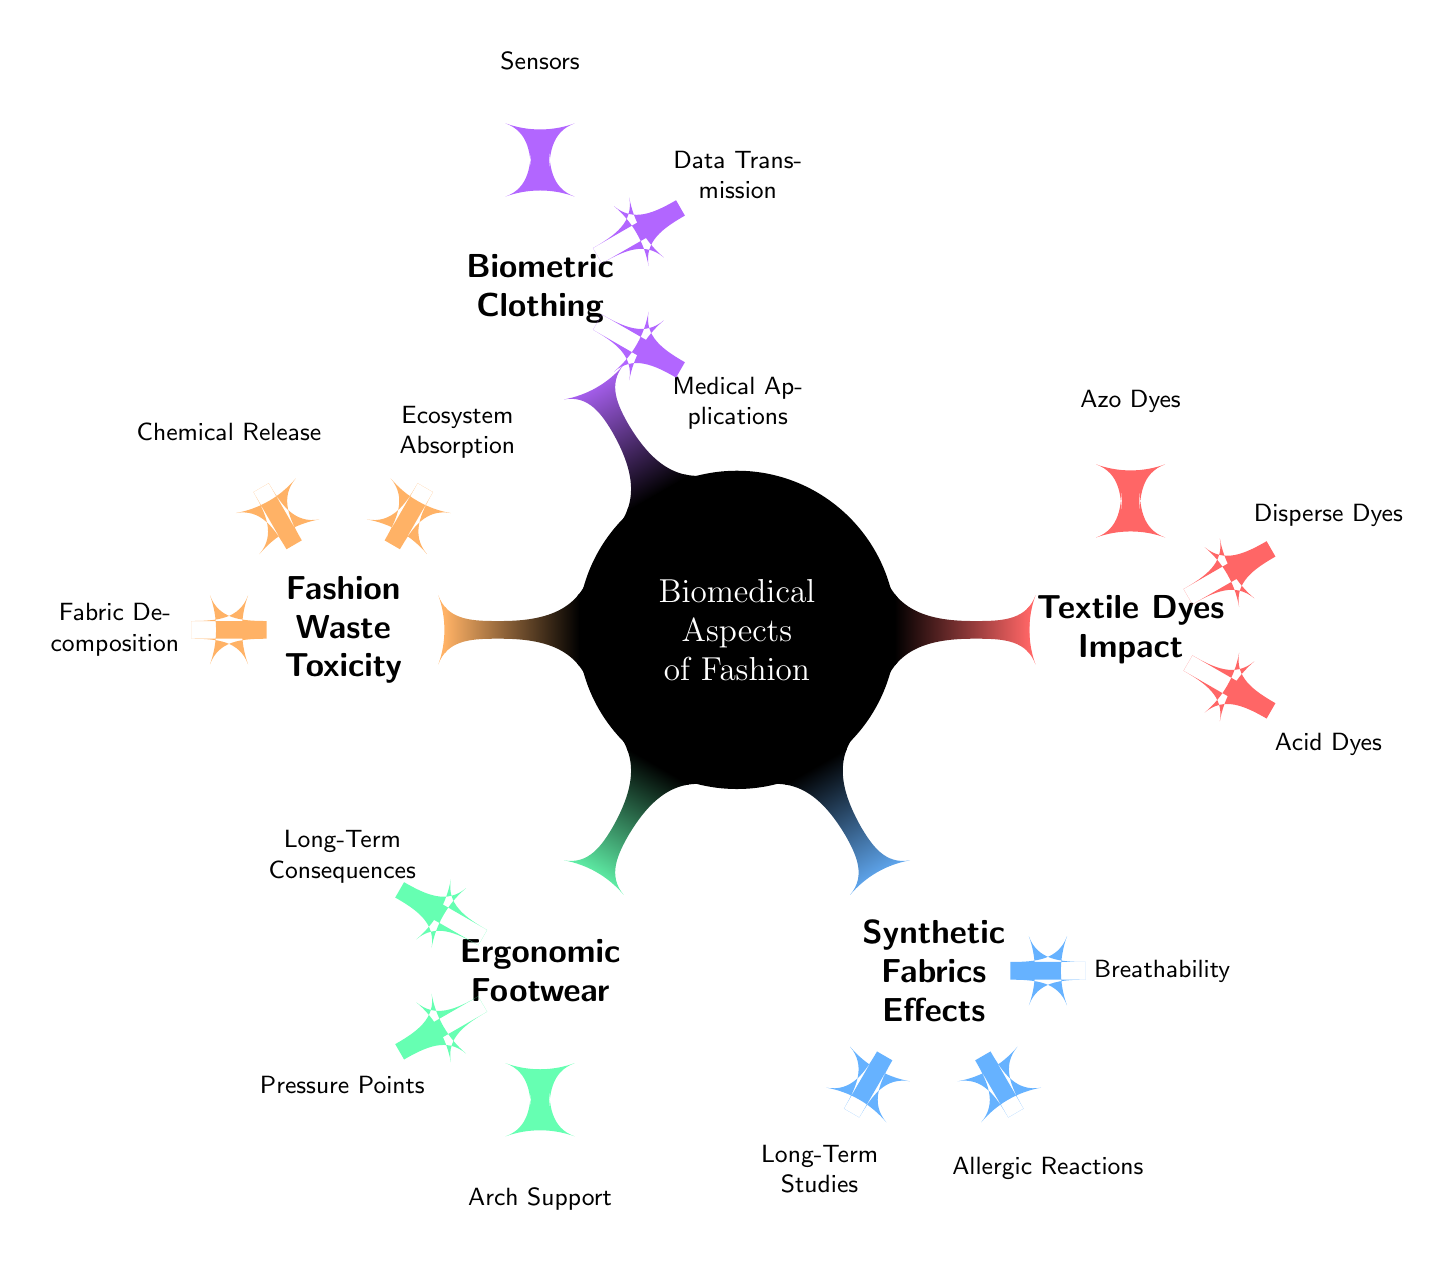What are the four main sections in the diagram? The diagram consists of five main sections: Textile Dyes Impact, Synthetic Fabrics Effects, Ergonomic Footwear, Fashion Waste Toxicity, and Biometric Clothing.
Answer: Textile Dyes Impact, Synthetic Fabrics Effects, Ergonomic Footwear, Fashion Waste Toxicity, Biometric Clothing How many types of textile dyes are identified in the diagram? There are three types of textile dyes identified in the diagram: Azo Dyes, Disperse Dyes, and Acid Dyes.
Answer: Three What is one health risk associated with synthetic fabrics? The diagram highlights Allergic Reactions as a potential health risk associated with synthetic fabrics.
Answer: Allergic Reactions Which section of the diagram addresses foot health? The Ergonomic Footwear section specifically addresses foot health through various subtopics including Arch Support and Pressure Points.
Answer: Ergonomic Footwear What does the Fashion Waste section detail about the ecosystem? The Fashion Waste section details Ecosystem Absorption, indicating how released chemicals from fabric decomposition enter the ecosystem.
Answer: Ecosystem Absorption How many subtopics does the Biometric Clothing section have? The Biometric Clothing section has three subtopics: Sensors, Data Transmission, and Medical Applications, which totals to three.
Answer: Three Which type of dye is commonly associated with allergic reactions? The diagram does not specify a type of dye commonly associated with allergic reactions, but allergic reactions are mentioned under Textile Dyes Impact.
Answer: Allergic Reactions What are the potential long-term effects mentioned for ergonomic footwear? Long-Term Consequences are mentioned as potential effects of ergonomic footwear design, indicating concerns over prolonged shoe use.
Answer: Long-Term Consequences 